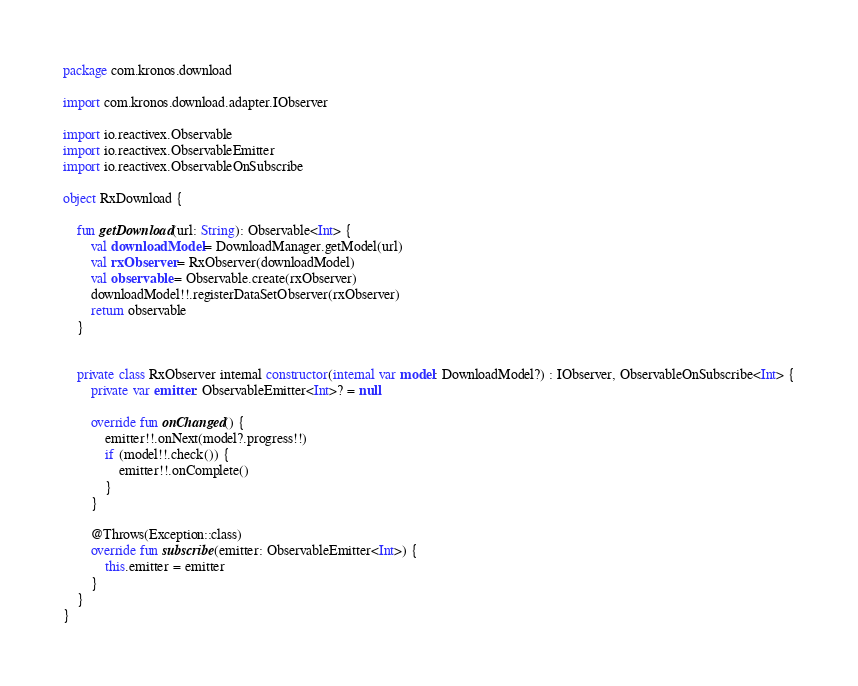<code> <loc_0><loc_0><loc_500><loc_500><_Kotlin_>package com.kronos.download

import com.kronos.download.adapter.IObserver

import io.reactivex.Observable
import io.reactivex.ObservableEmitter
import io.reactivex.ObservableOnSubscribe

object RxDownload {

    fun getDownload(url: String): Observable<Int> {
        val downloadModel = DownloadManager.getModel(url)
        val rxObserver = RxObserver(downloadModel)
        val observable = Observable.create(rxObserver)
        downloadModel!!.registerDataSetObserver(rxObserver)
        return observable
    }


    private class RxObserver internal constructor(internal var model: DownloadModel?) : IObserver, ObservableOnSubscribe<Int> {
        private var emitter: ObservableEmitter<Int>? = null

        override fun onChanged() {
            emitter!!.onNext(model?.progress!!)
            if (model!!.check()) {
                emitter!!.onComplete()
            }
        }

        @Throws(Exception::class)
        override fun subscribe(emitter: ObservableEmitter<Int>) {
            this.emitter = emitter
        }
    }
}
</code> 